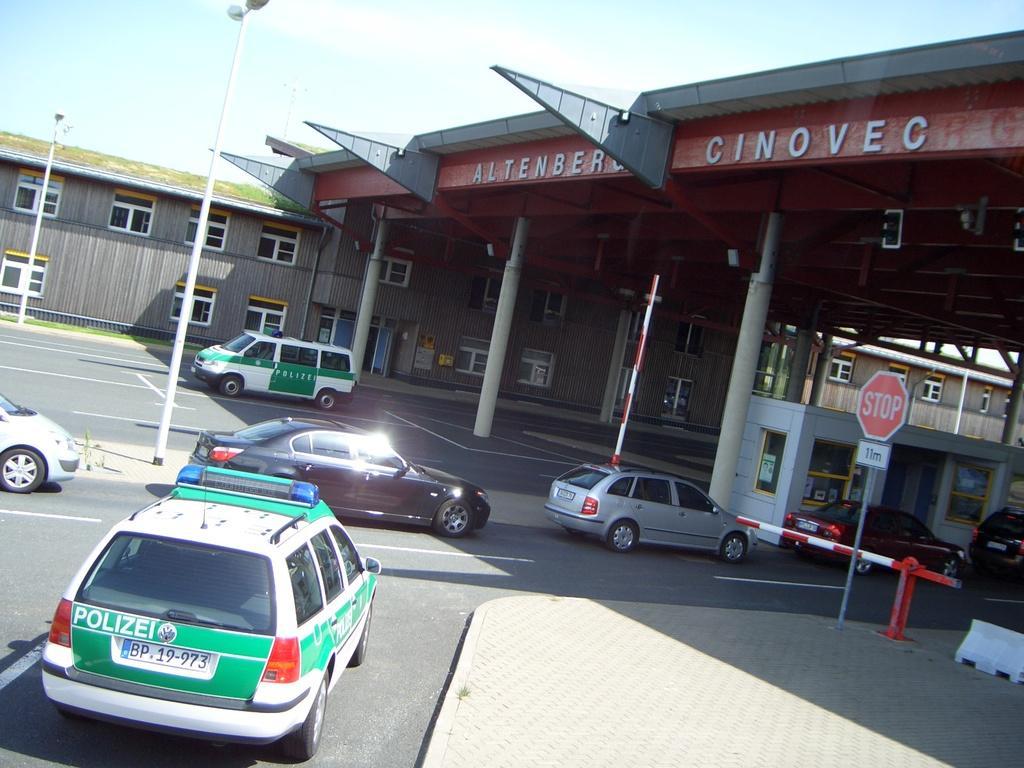How would you summarize this image in a sentence or two? In this image we can see a toll plaza, we can see a building with few windows, door and at the top of the toll plaza we can a name written on it, there we can see a few vehicles on the road, a signboard, a gate, few pillars, few lights attached to the poles and the sky. 